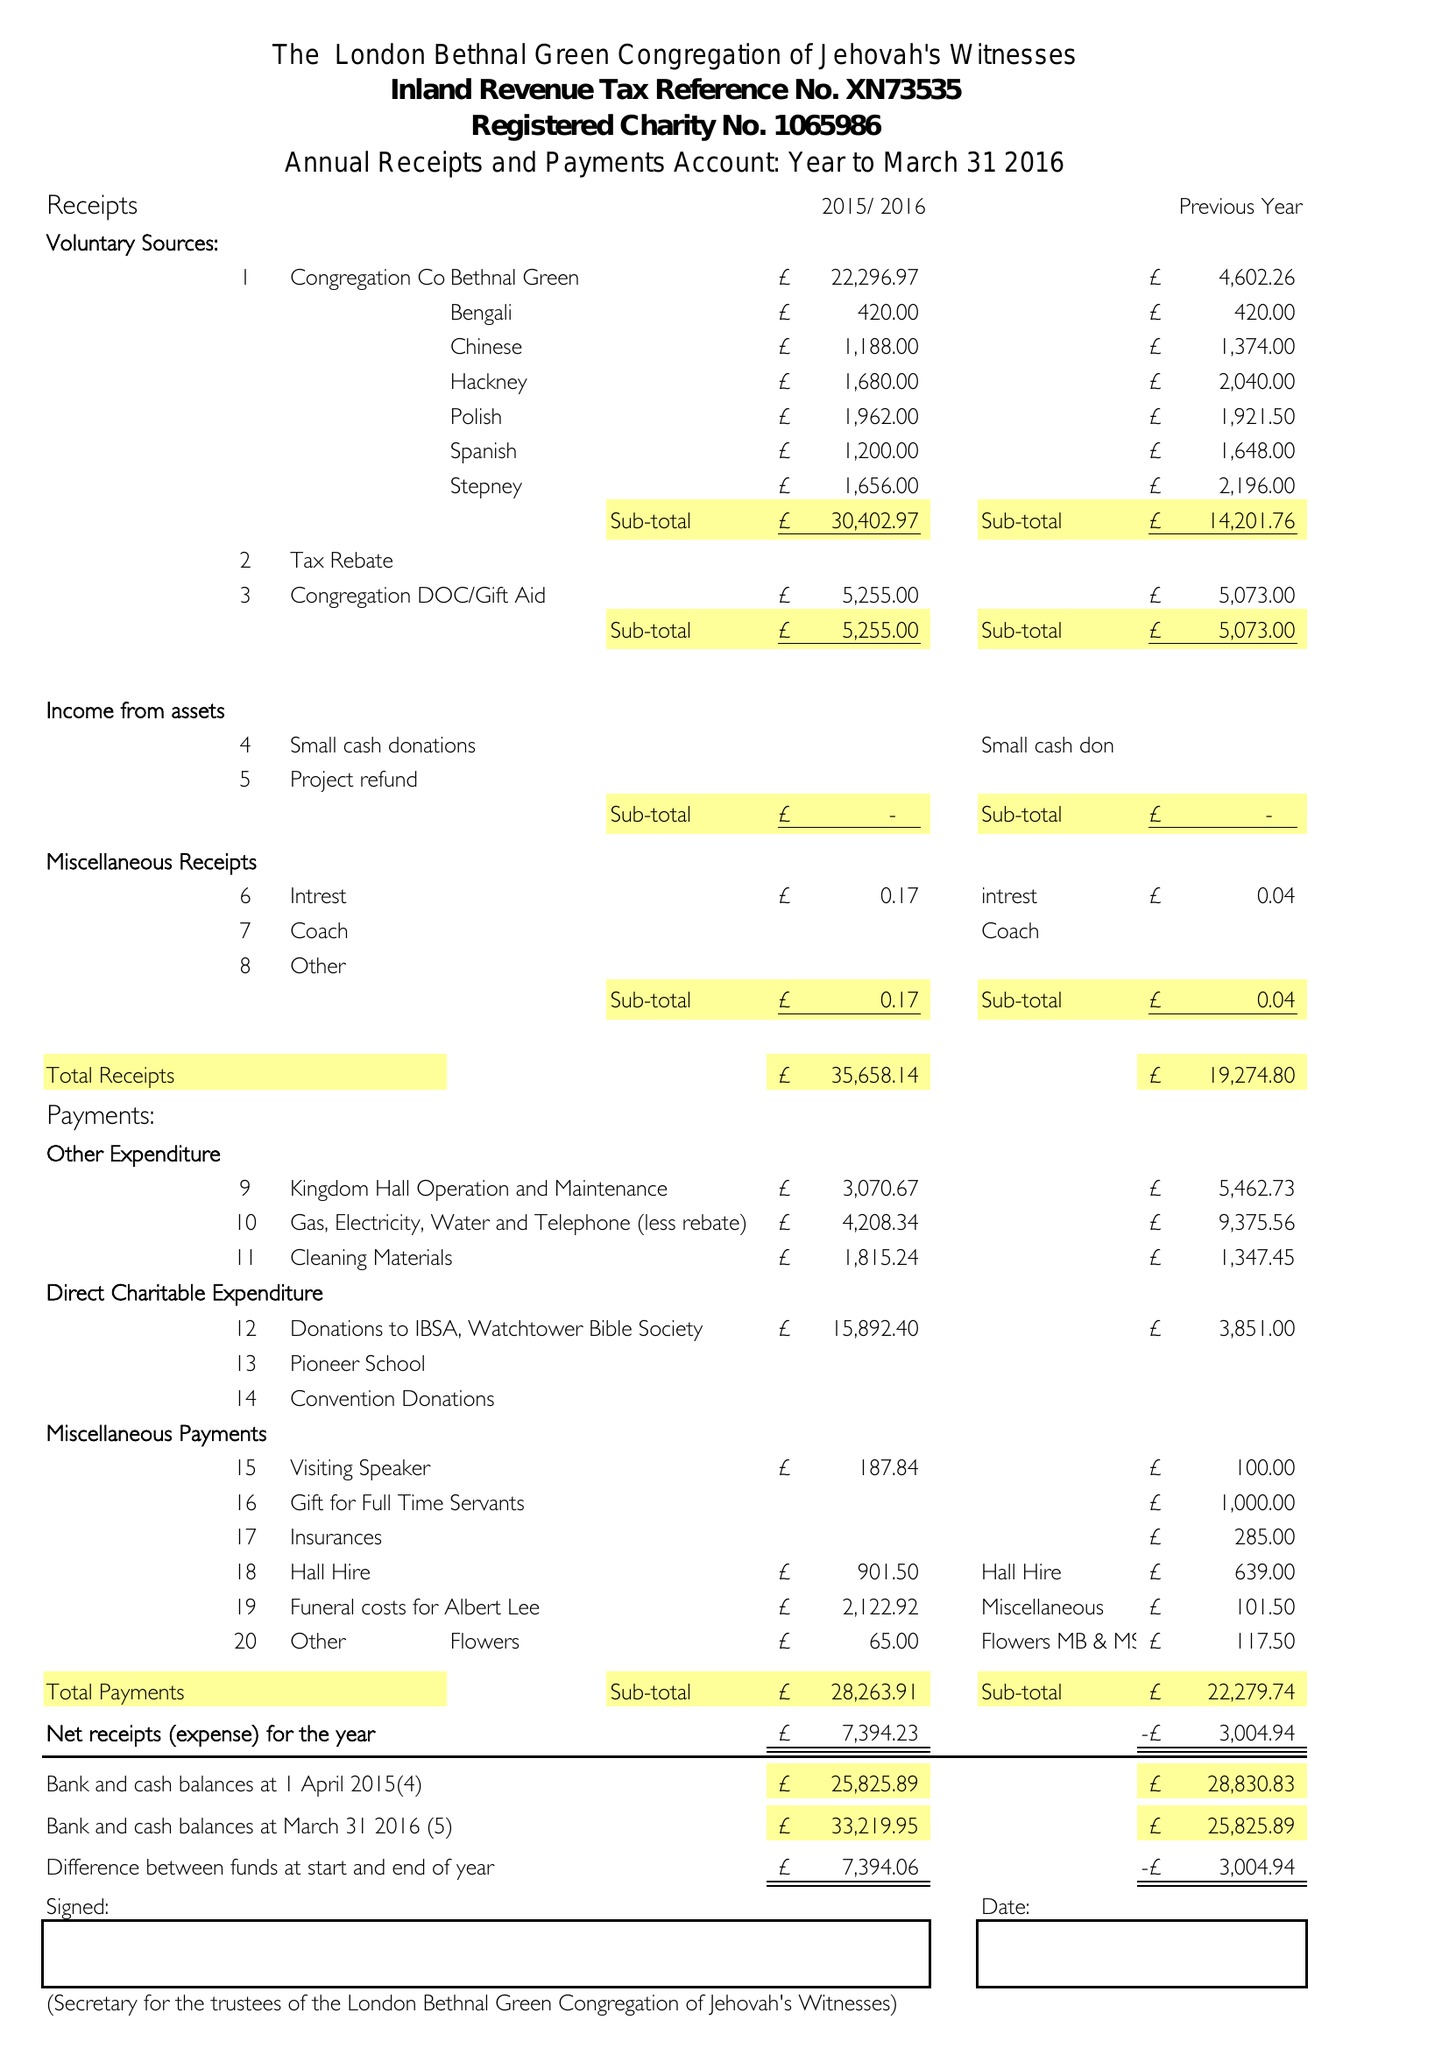What is the value for the income_annually_in_british_pounds?
Answer the question using a single word or phrase. 35658.00 